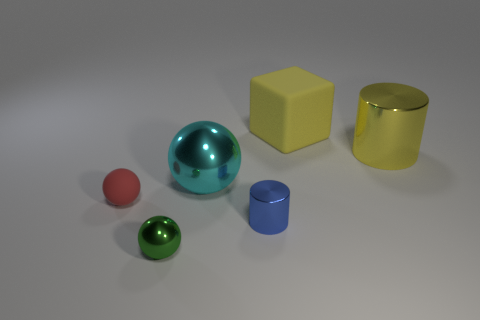Do the large cylinder and the matte block have the same color?
Provide a short and direct response. Yes. What is the color of the sphere in front of the small red sphere?
Your answer should be compact. Green. What shape is the tiny green object?
Make the answer very short. Sphere. There is a cylinder in front of the large thing that is left of the yellow rubber object; is there a matte ball on the right side of it?
Offer a very short reply. No. What is the color of the shiny sphere that is behind the metal ball that is in front of the small shiny object that is behind the small green metallic ball?
Provide a short and direct response. Cyan. What is the material of the other large object that is the same shape as the red thing?
Offer a terse response. Metal. What size is the sphere that is to the left of the sphere in front of the tiny cylinder?
Make the answer very short. Small. There is a thing in front of the blue thing; what is it made of?
Offer a terse response. Metal. There is a yellow cylinder that is made of the same material as the green ball; what is its size?
Provide a succinct answer. Large. What number of other small things have the same shape as the tiny blue shiny thing?
Provide a short and direct response. 0. 